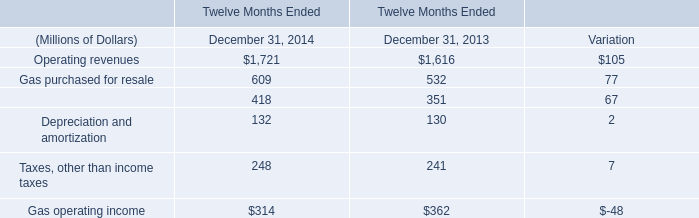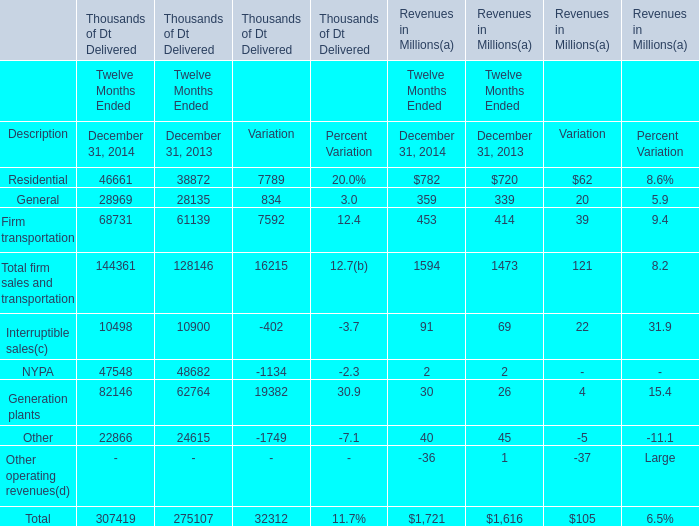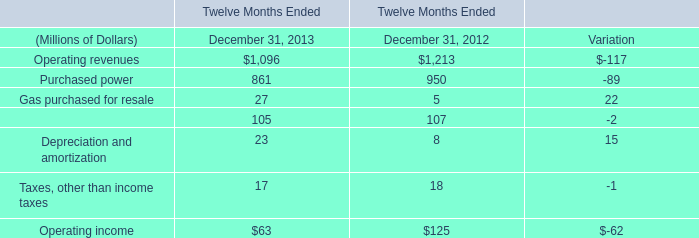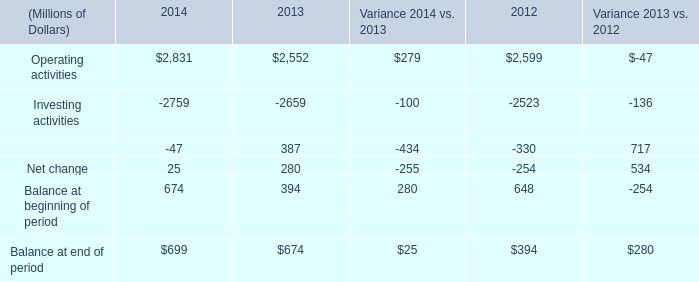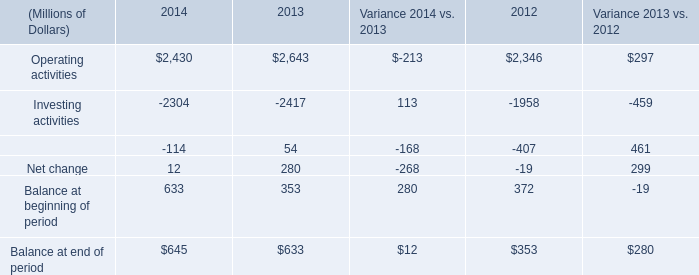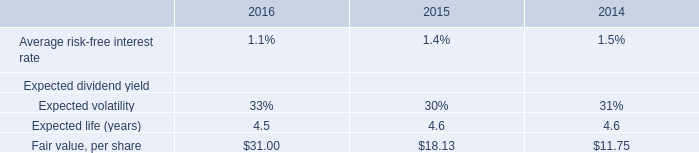what is the percent change in the fair value per share between 2014 and 2016? 
Computations: ((31 - 11.75) / 11.75)
Answer: 1.6383. 